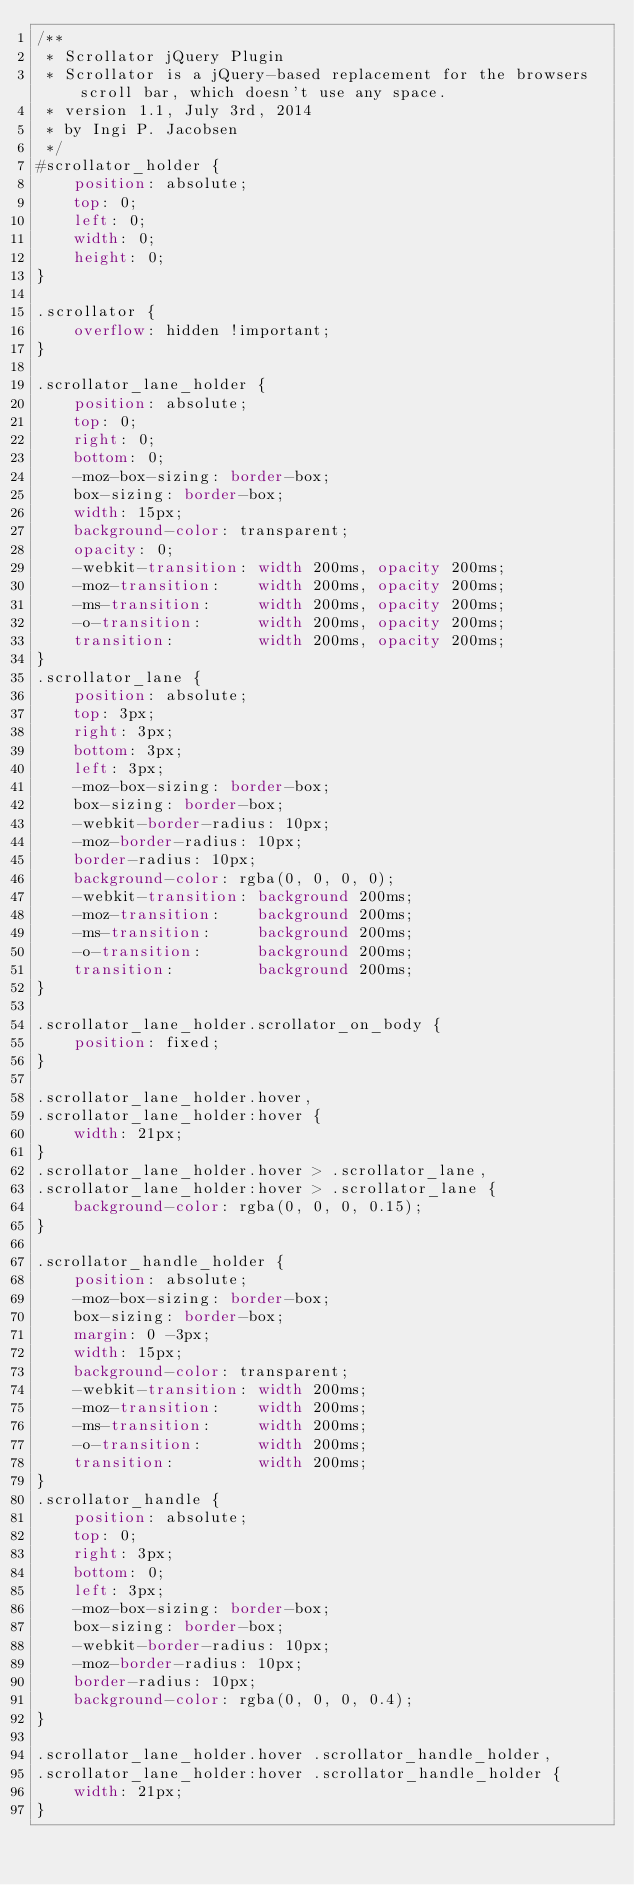<code> <loc_0><loc_0><loc_500><loc_500><_CSS_>/**
 * Scrollator jQuery Plugin
 * Scrollator is a jQuery-based replacement for the browsers scroll bar, which doesn't use any space.
 * version 1.1, July 3rd, 2014
 * by Ingi P. Jacobsen
 */
#scrollator_holder {
	position: absolute;
	top: 0;
	left: 0;
	width: 0;
	height: 0;
}

.scrollator {
	overflow: hidden !important;
}

.scrollator_lane_holder {
	position: absolute;
	top: 0;
	right: 0;
	bottom: 0;
	-moz-box-sizing: border-box;
	box-sizing: border-box;
	width: 15px;
	background-color: transparent;
	opacity: 0;
	-webkit-transition: width 200ms, opacity 200ms;
	-moz-transition:    width 200ms, opacity 200ms;
	-ms-transition:     width 200ms, opacity 200ms;
	-o-transition:      width 200ms, opacity 200ms;
	transition:         width 200ms, opacity 200ms;
}
.scrollator_lane {
	position: absolute;
	top: 3px;
	right: 3px;
	bottom: 3px;
	left: 3px;
	-moz-box-sizing: border-box;
	box-sizing: border-box;
	-webkit-border-radius: 10px;
	-moz-border-radius: 10px;
	border-radius: 10px;
	background-color: rgba(0, 0, 0, 0);
	-webkit-transition: background 200ms;
	-moz-transition:    background 200ms;
	-ms-transition:     background 200ms;
	-o-transition:      background 200ms;
	transition:         background 200ms;
}

.scrollator_lane_holder.scrollator_on_body {
	position: fixed;
}

.scrollator_lane_holder.hover, 
.scrollator_lane_holder:hover {
	width: 21px;
}
.scrollator_lane_holder.hover > .scrollator_lane, 
.scrollator_lane_holder:hover > .scrollator_lane {
	background-color: rgba(0, 0, 0, 0.15);
}

.scrollator_handle_holder {
	position: absolute;
	-moz-box-sizing: border-box;
	box-sizing: border-box;
	margin: 0 -3px;
	width: 15px;
	background-color: transparent;
	-webkit-transition: width 200ms;
	-moz-transition:    width 200ms;
	-ms-transition:     width 200ms;
	-o-transition:      width 200ms;
	transition:         width 200ms;
}
.scrollator_handle {
	position: absolute;
	top: 0;
	right: 3px;
	bottom: 0;
	left: 3px;
	-moz-box-sizing: border-box;
	box-sizing: border-box;
	-webkit-border-radius: 10px;
	-moz-border-radius: 10px;
	border-radius: 10px;
	background-color: rgba(0, 0, 0, 0.4);
}

.scrollator_lane_holder.hover .scrollator_handle_holder, 
.scrollator_lane_holder:hover .scrollator_handle_holder {
	width: 21px;
}</code> 